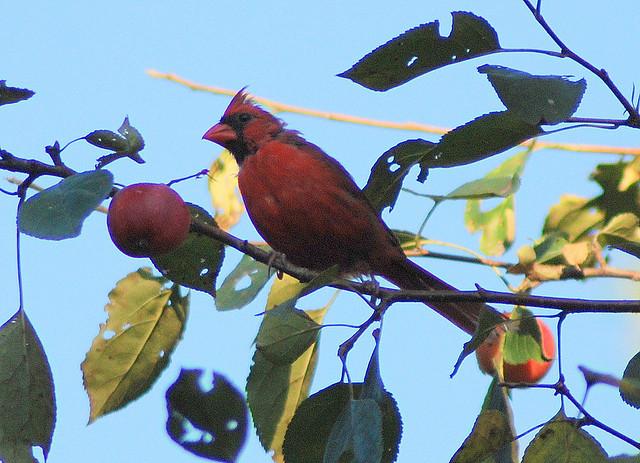What is the primary color of the bird?
Be succinct. Red. Is there a cardinal in the tree?
Be succinct. Yes. What type of a tree is that?
Be succinct. Apple. 